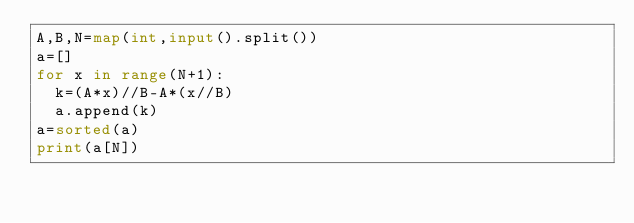<code> <loc_0><loc_0><loc_500><loc_500><_Python_>A,B,N=map(int,input().split())
a=[]
for x in range(N+1):
  k=(A*x)//B-A*(x//B)
  a.append(k)
a=sorted(a)
print(a[N])</code> 